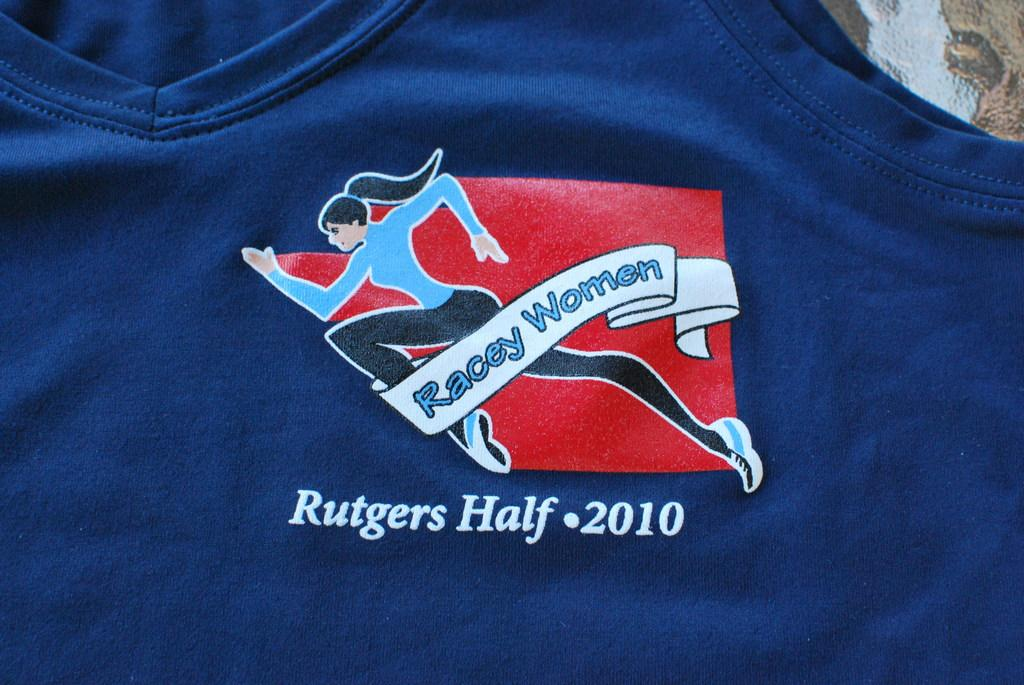<image>
Share a concise interpretation of the image provided. A shirt says, "Racey Women" and "Rutgers Half - 2010." 